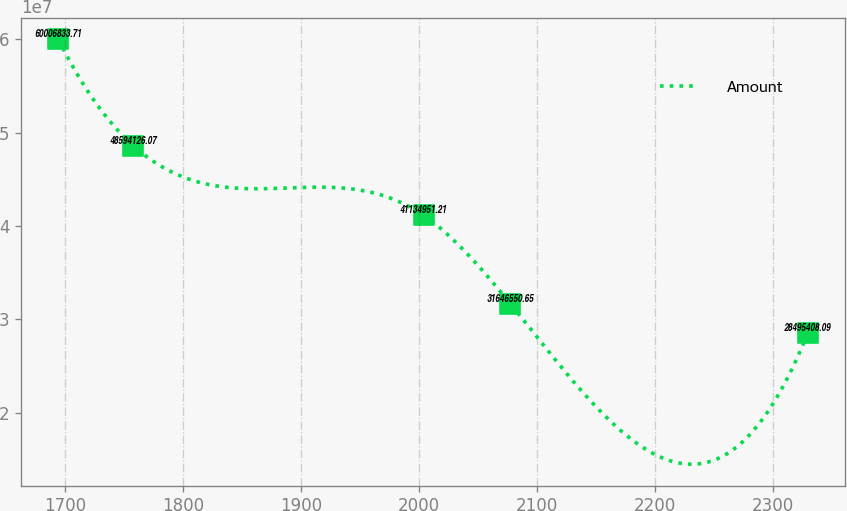<chart> <loc_0><loc_0><loc_500><loc_500><line_chart><ecel><fcel>Amount<nl><fcel>1694.61<fcel>6.00068e+07<nl><fcel>1758.06<fcel>4.85941e+07<nl><fcel>2003.88<fcel>4.1135e+07<nl><fcel>2077.45<fcel>3.16466e+07<nl><fcel>2329.16<fcel>2.84954e+07<nl></chart> 